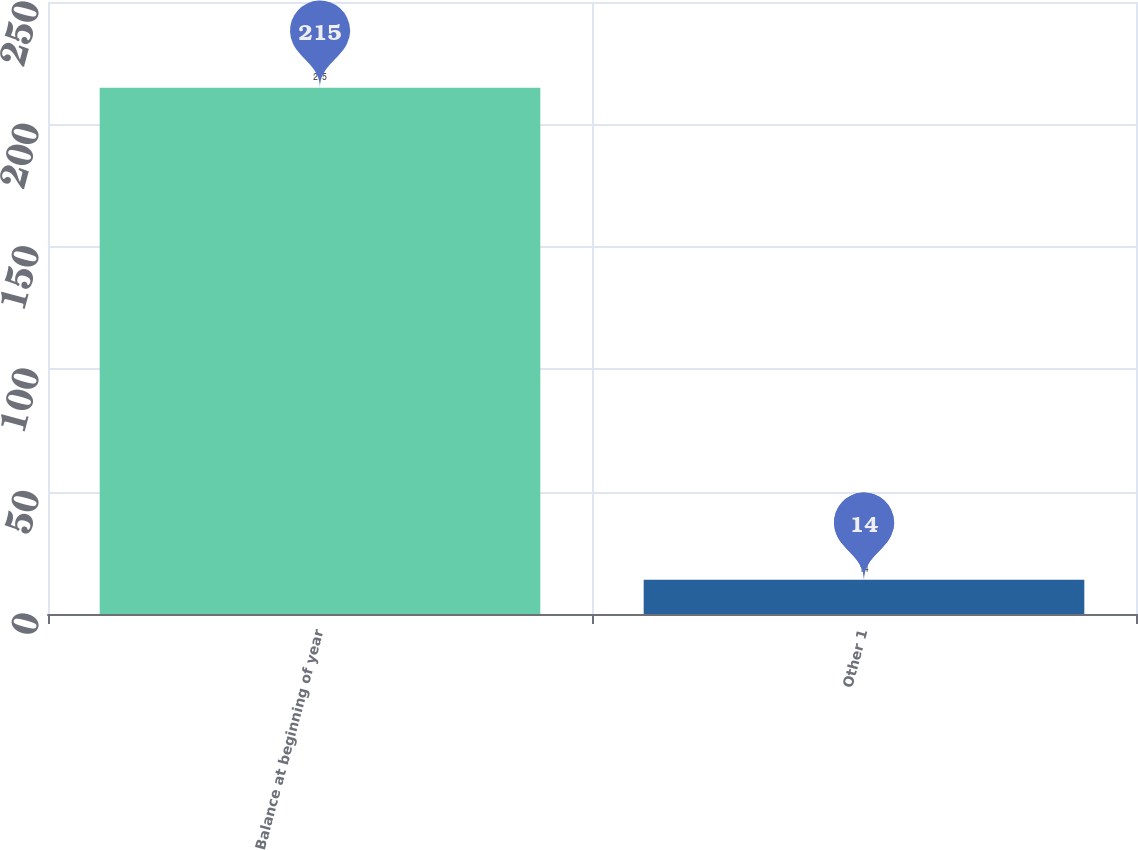<chart> <loc_0><loc_0><loc_500><loc_500><bar_chart><fcel>Balance at beginning of year<fcel>Other 1<nl><fcel>215<fcel>14<nl></chart> 